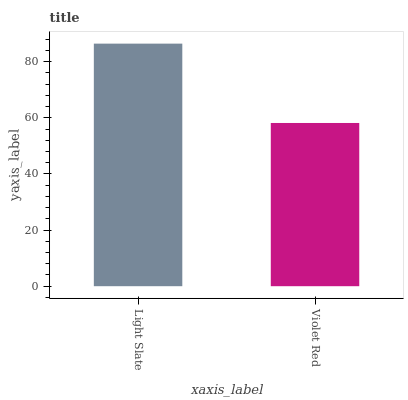Is Violet Red the minimum?
Answer yes or no. Yes. Is Light Slate the maximum?
Answer yes or no. Yes. Is Violet Red the maximum?
Answer yes or no. No. Is Light Slate greater than Violet Red?
Answer yes or no. Yes. Is Violet Red less than Light Slate?
Answer yes or no. Yes. Is Violet Red greater than Light Slate?
Answer yes or no. No. Is Light Slate less than Violet Red?
Answer yes or no. No. Is Light Slate the high median?
Answer yes or no. Yes. Is Violet Red the low median?
Answer yes or no. Yes. Is Violet Red the high median?
Answer yes or no. No. Is Light Slate the low median?
Answer yes or no. No. 